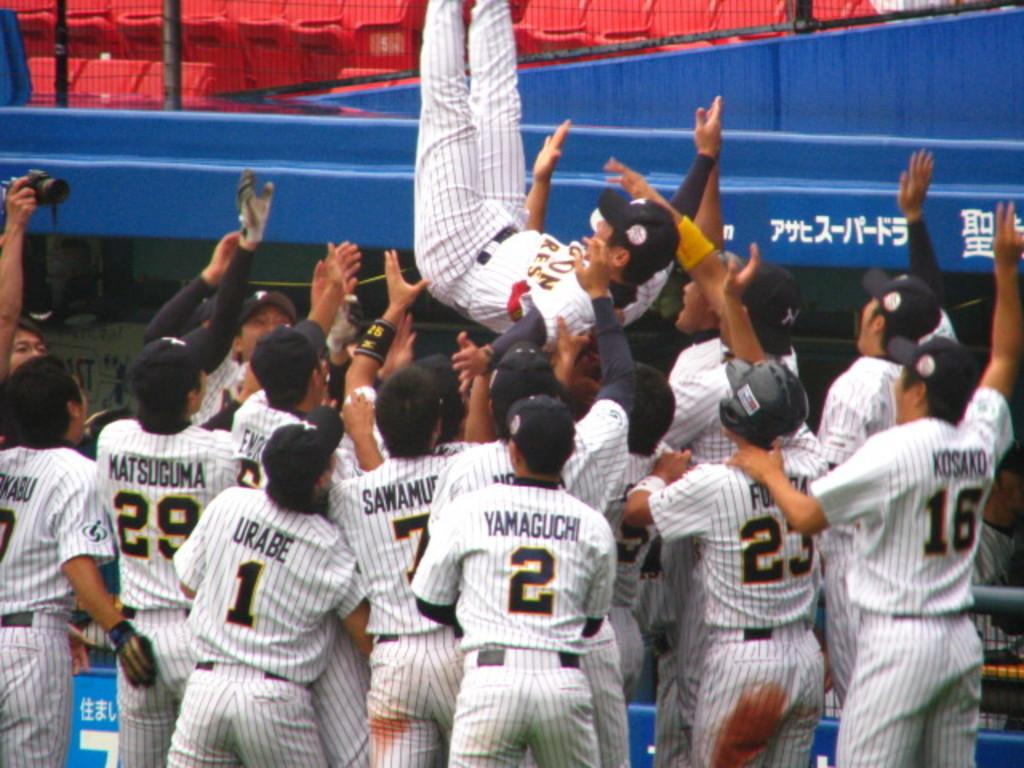<image>
Share a concise interpretation of the image provided. A baseball player is being tossed in the air by other players including numbers 29, 1, 2, 23 and 16. 